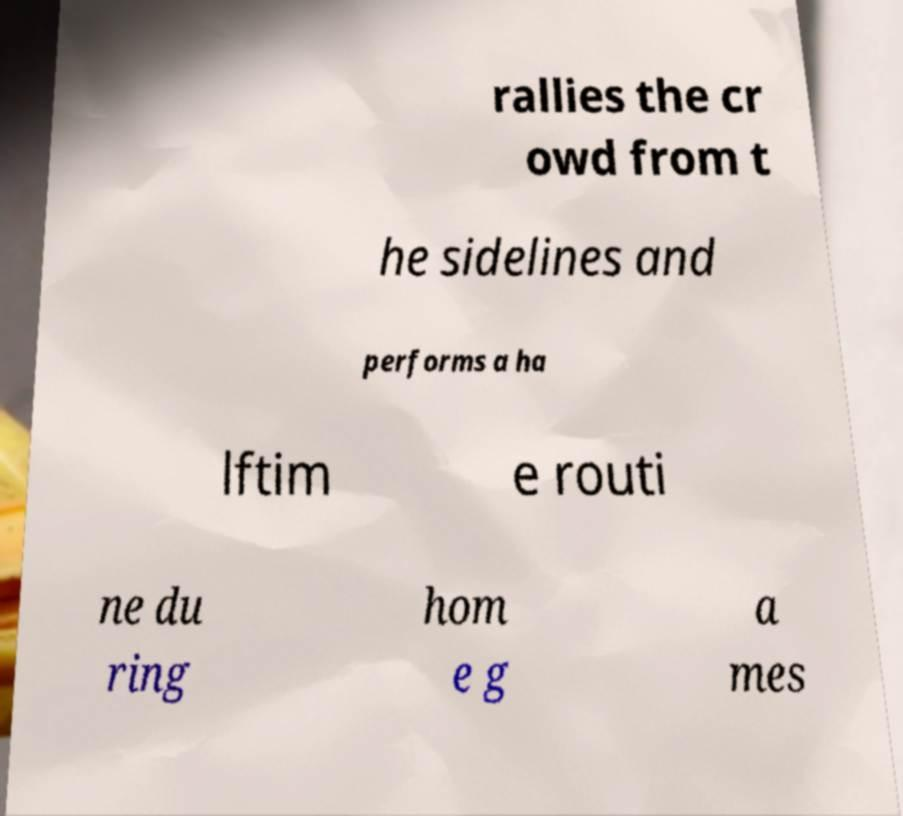Could you extract and type out the text from this image? rallies the cr owd from t he sidelines and performs a ha lftim e routi ne du ring hom e g a mes 